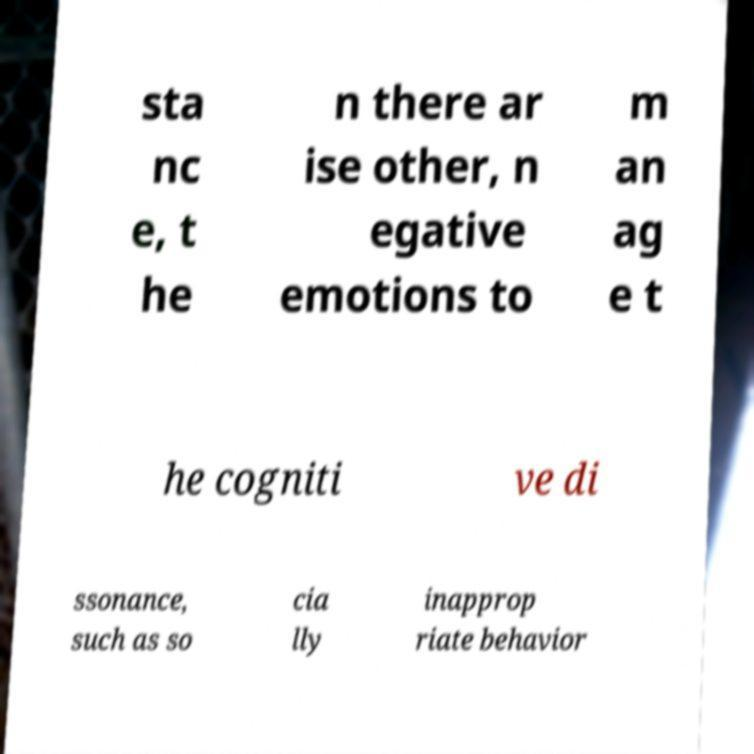Can you read and provide the text displayed in the image?This photo seems to have some interesting text. Can you extract and type it out for me? sta nc e, t he n there ar ise other, n egative emotions to m an ag e t he cogniti ve di ssonance, such as so cia lly inapprop riate behavior 